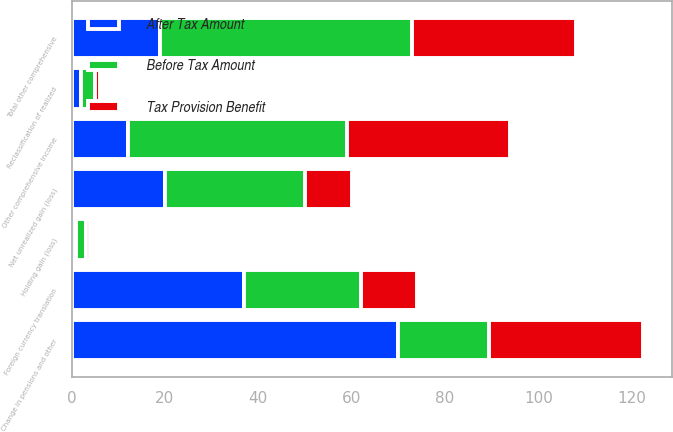Convert chart to OTSL. <chart><loc_0><loc_0><loc_500><loc_500><stacked_bar_chart><ecel><fcel>Change in pensions and other<fcel>Foreign currency translation<fcel>Holding gain (loss)<fcel>Reclassification of realized<fcel>Net unrealized gain (loss)<fcel>Other comprehensive income<fcel>Total other comprehensive<nl><fcel>Before Tax Amount<fcel>19.5<fcel>25<fcel>2<fcel>3<fcel>30<fcel>47<fcel>54<nl><fcel>Tax Provision Benefit<fcel>33<fcel>12<fcel>1<fcel>1<fcel>10<fcel>35<fcel>35<nl><fcel>After Tax Amount<fcel>70<fcel>37<fcel>1<fcel>2<fcel>20<fcel>12<fcel>19<nl></chart> 